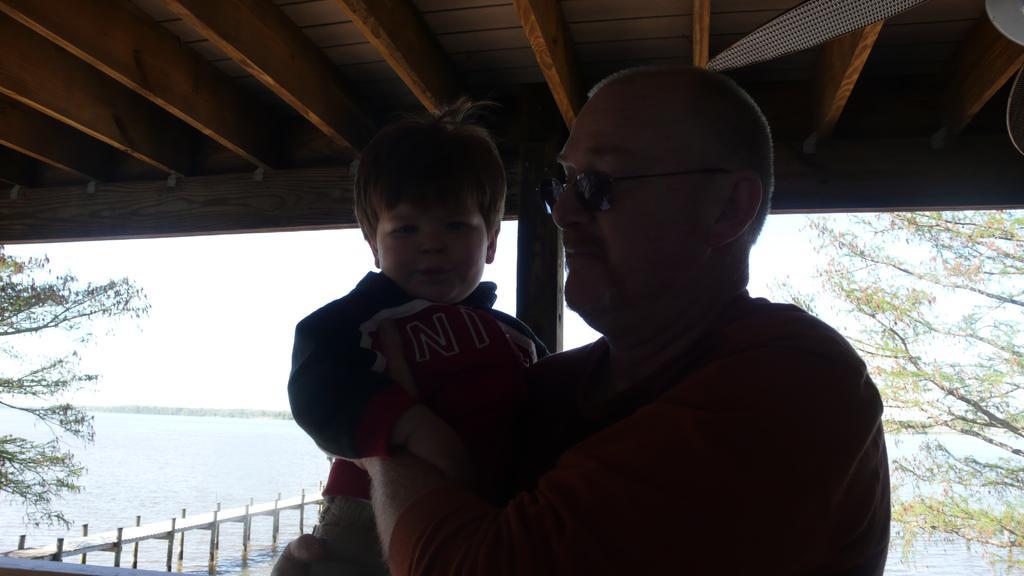In one or two sentences, can you explain what this image depicts? In this picture there is a person holding a baby in his hands and there is a wooden roof above them and there is water in the background and there are trees on either sides of them. 